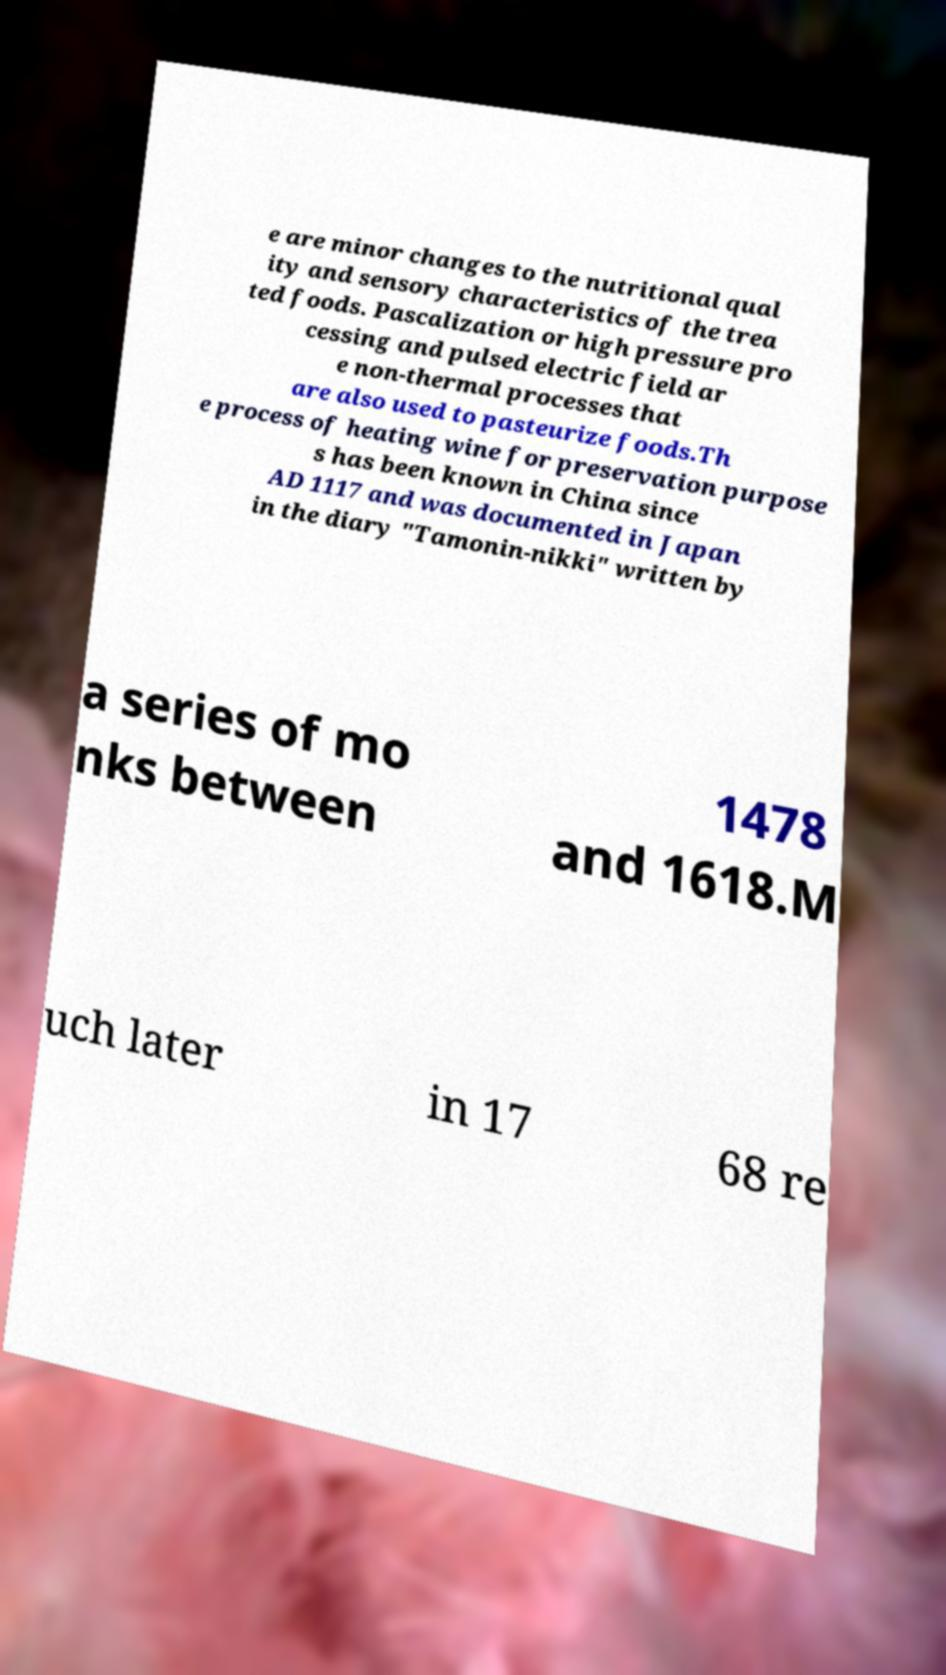Could you assist in decoding the text presented in this image and type it out clearly? e are minor changes to the nutritional qual ity and sensory characteristics of the trea ted foods. Pascalization or high pressure pro cessing and pulsed electric field ar e non-thermal processes that are also used to pasteurize foods.Th e process of heating wine for preservation purpose s has been known in China since AD 1117 and was documented in Japan in the diary "Tamonin-nikki" written by a series of mo nks between 1478 and 1618.M uch later in 17 68 re 